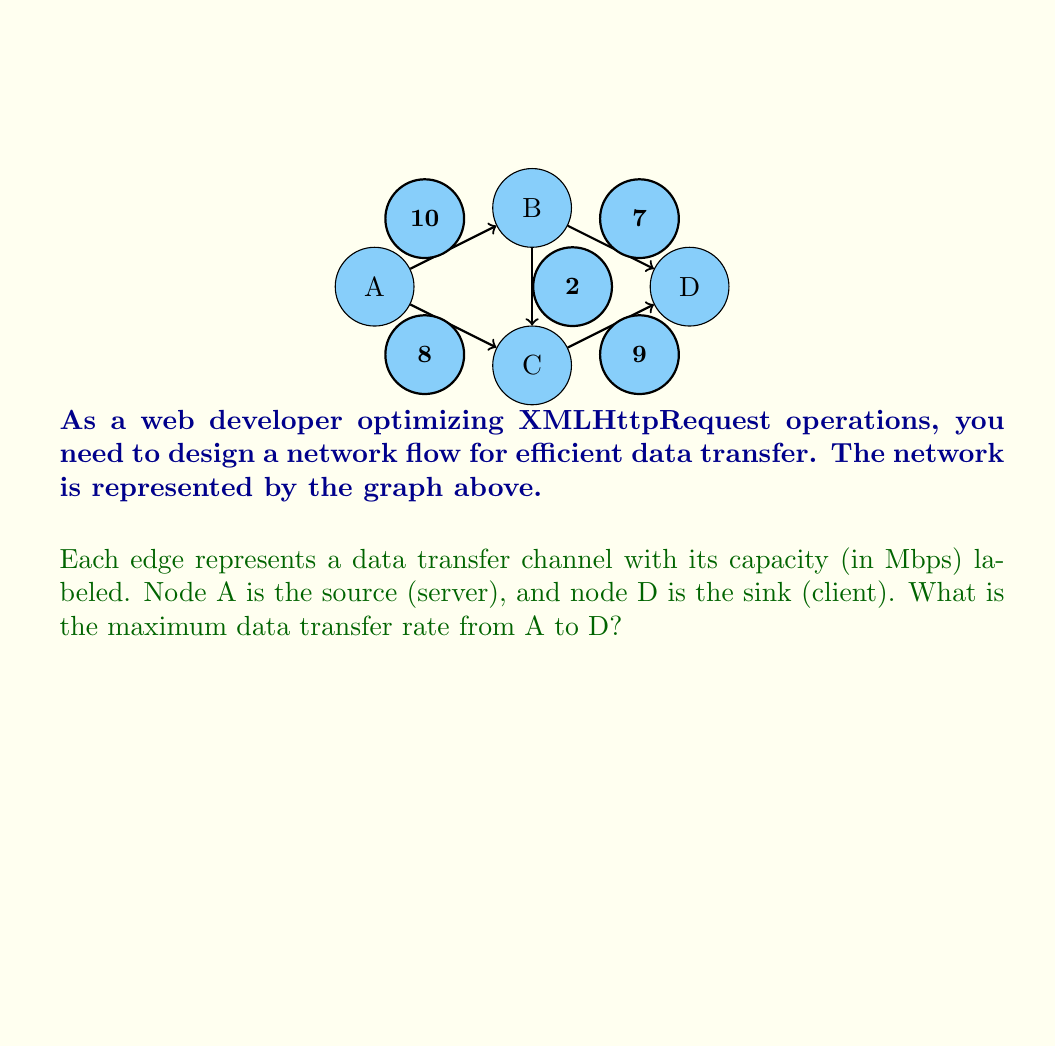Teach me how to tackle this problem. To solve this network flow problem, we'll use the Ford-Fulkerson algorithm:

1) Initialize flow to 0 for all edges.

2) Find an augmenting path from A to D:
   Path 1: A → B → D (min capacity: 7)
   Update flow: A → B: 7, B → D: 7
   Residual graph:
   A → B: 3, B → A: 7, A → C: 8, B → D: 0, D → B: 7, B → C: 2, C → D: 9

3) Find another augmenting path:
   Path 2: A → C → D (min capacity: 8)
   Update flow: A → C: 8, C → D: 8
   Residual graph:
   A → B: 3, B → A: 7, A → C: 0, C → A: 8, B → D: 0, D → B: 7, B → C: 2, C → D: 1, D → C: 8

4) Find another augmenting path:
   Path 3: A → B → C → D (min capacity: 1)
   Update flow: A → B: 1, B → C: 1, C → D: 1
   Residual graph:
   A → B: 2, B → A: 8, A → C: 0, C → A: 8, B → D: 0, D → B: 7, B → C: 1, C → B: 1, C → D: 0, D → C: 9

5) No more augmenting paths exist.

6) Sum the flows into D: 7 + 8 + 1 = 16

Therefore, the maximum flow from A to D is 16 Mbps.
Answer: 16 Mbps 